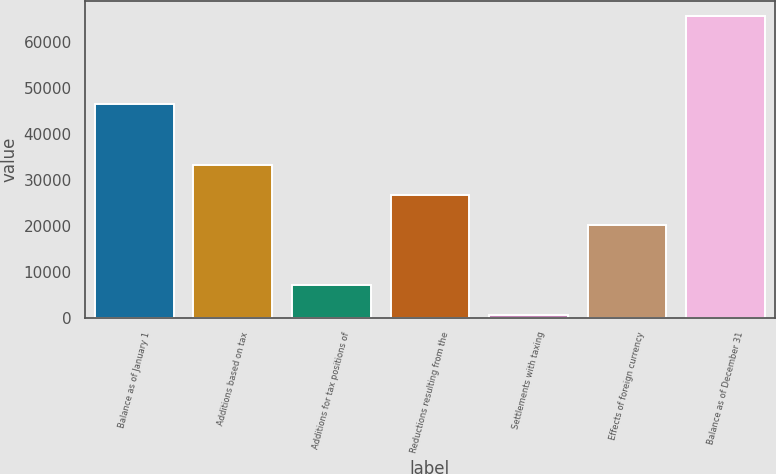Convert chart to OTSL. <chart><loc_0><loc_0><loc_500><loc_500><bar_chart><fcel>Balance as of January 1<fcel>Additions based on tax<fcel>Additions for tax positions of<fcel>Reductions resulting from the<fcel>Settlements with taxing<fcel>Effects of foreign currency<fcel>Balance as of December 31<nl><fcel>46434<fcel>33143<fcel>7152.6<fcel>26645.4<fcel>655<fcel>20147.8<fcel>65631<nl></chart> 